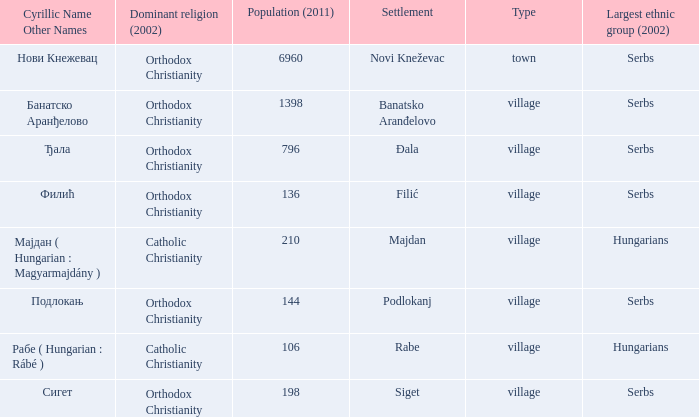What is the cyrillic and other name of rabe? Рабе ( Hungarian : Rábé ). Could you help me parse every detail presented in this table? {'header': ['Cyrillic Name Other Names', 'Dominant religion (2002)', 'Population (2011)', 'Settlement', 'Type', 'Largest ethnic group (2002)'], 'rows': [['Нови Кнежевац', 'Orthodox Christianity', '6960', 'Novi Kneževac', 'town', 'Serbs'], ['Банатско Аранђелово', 'Orthodox Christianity', '1398', 'Banatsko Aranđelovo', 'village', 'Serbs'], ['Ђала', 'Orthodox Christianity', '796', 'Đala', 'village', 'Serbs'], ['Филић', 'Orthodox Christianity', '136', 'Filić', 'village', 'Serbs'], ['Мајдан ( Hungarian : Magyarmajdány )', 'Catholic Christianity', '210', 'Majdan', 'village', 'Hungarians'], ['Подлокањ', 'Orthodox Christianity', '144', 'Podlokanj', 'village', 'Serbs'], ['Рабе ( Hungarian : Rábé )', 'Catholic Christianity', '106', 'Rabe', 'village', 'Hungarians'], ['Сигет', 'Orthodox Christianity', '198', 'Siget', 'village', 'Serbs']]} 